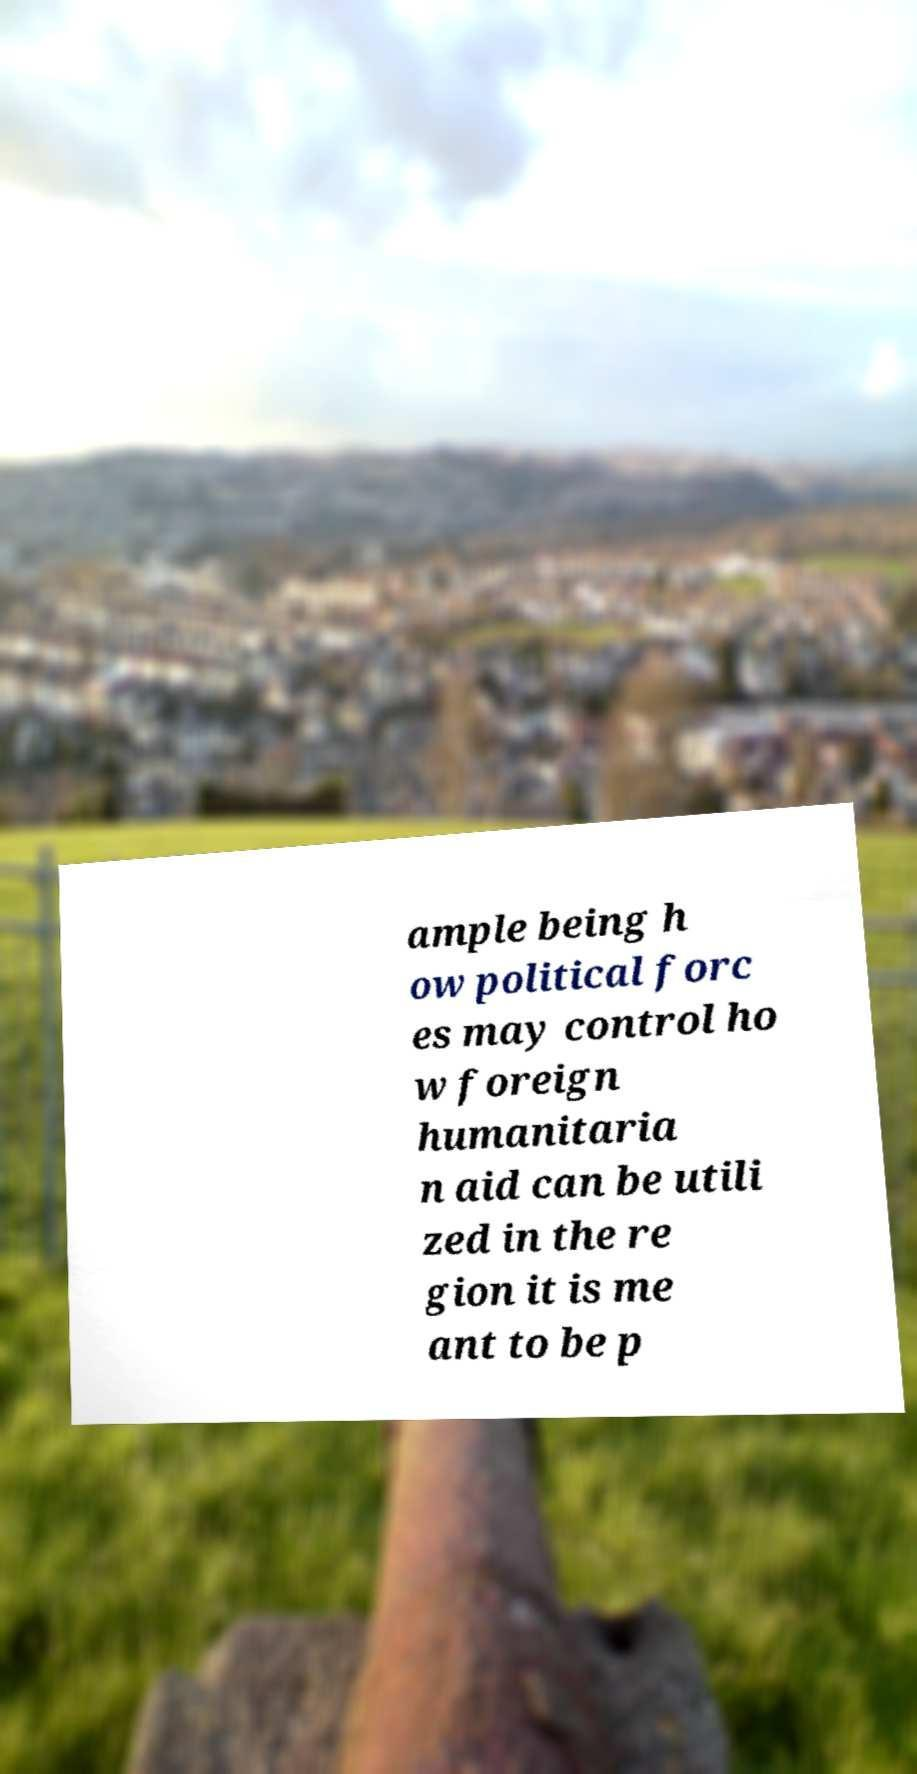What messages or text are displayed in this image? I need them in a readable, typed format. ample being h ow political forc es may control ho w foreign humanitaria n aid can be utili zed in the re gion it is me ant to be p 